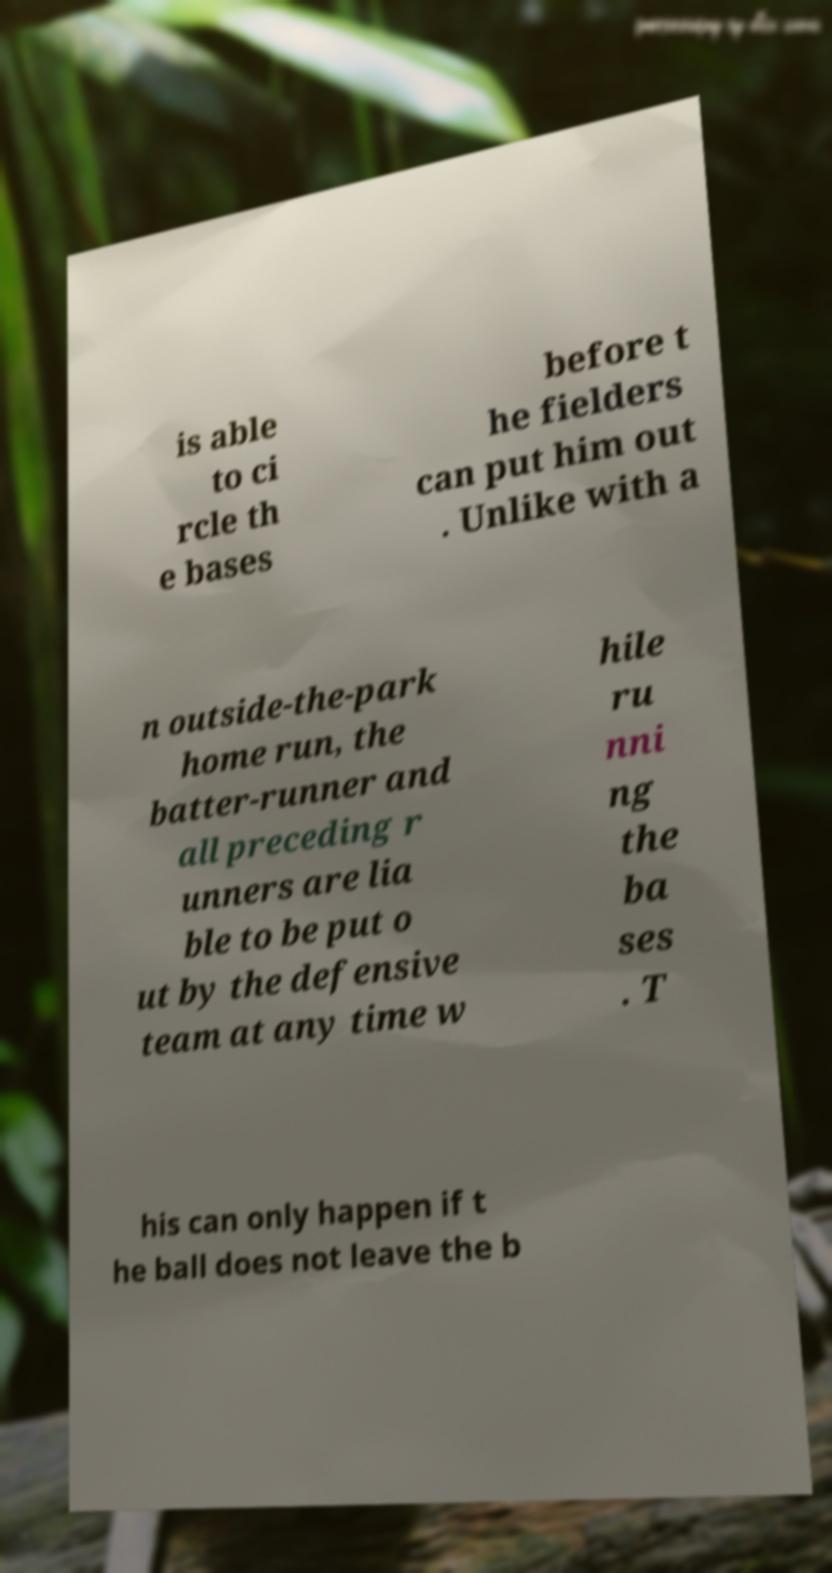I need the written content from this picture converted into text. Can you do that? is able to ci rcle th e bases before t he fielders can put him out . Unlike with a n outside-the-park home run, the batter-runner and all preceding r unners are lia ble to be put o ut by the defensive team at any time w hile ru nni ng the ba ses . T his can only happen if t he ball does not leave the b 